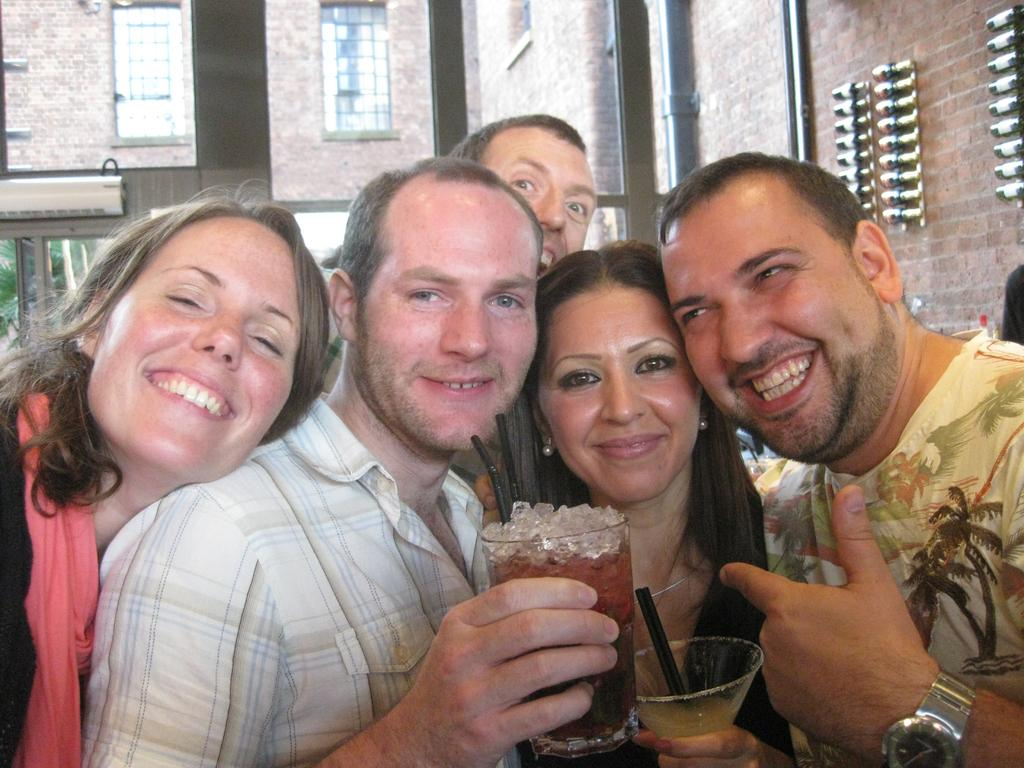How many persons are in the image? There are persons standing in the image. What is the facial expression of the persons in the image? The persons are smiling. What are two persons holding in the image? Two persons are holding glasses. What can be seen in the background of the image? There is a building, windows, and a wall in the background of the image. What type of street can be seen in the image? There is no street present in the image. How do the persons express their feelings of hate towards each other in the image? The persons are not expressing hate towards each other; they are smiling. 